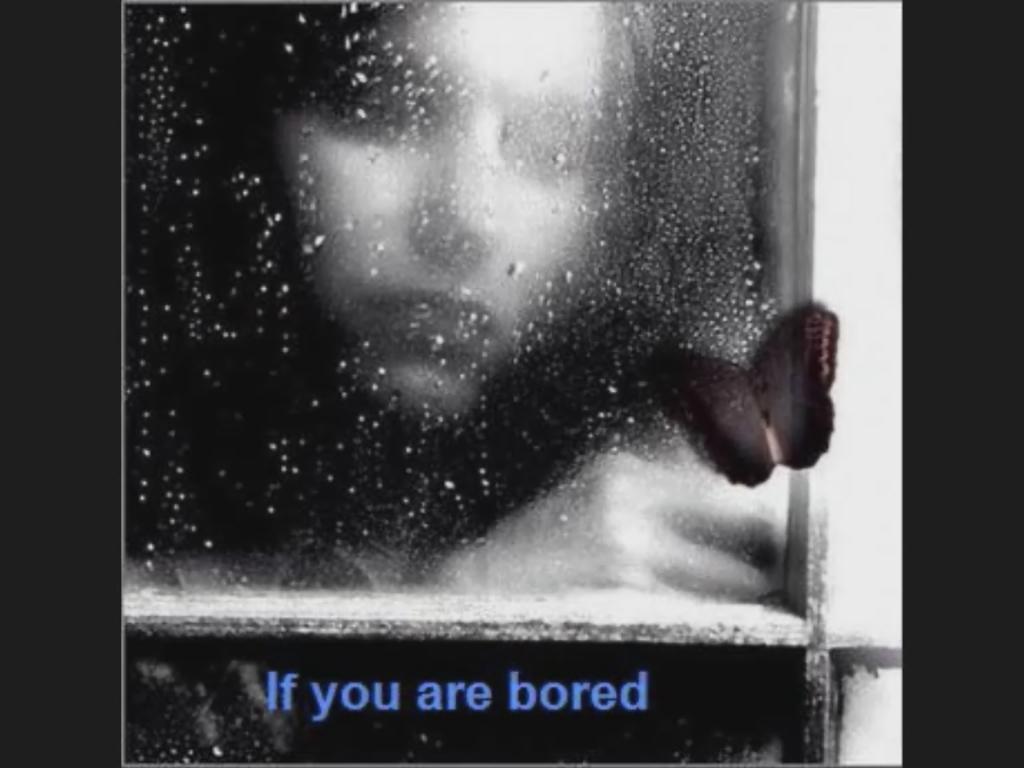Could you give a brief overview of what you see in this image? In this image we can see a person through the glass frame and there is a butterfly. At the bottom there is text. 